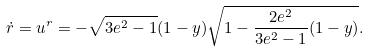Convert formula to latex. <formula><loc_0><loc_0><loc_500><loc_500>\dot { r } = u ^ { r } = - \sqrt { 3 e ^ { 2 } - 1 } ( 1 - y ) \sqrt { 1 - \frac { 2 e ^ { 2 } } { 3 e ^ { 2 } - 1 } ( 1 - y ) } .</formula> 